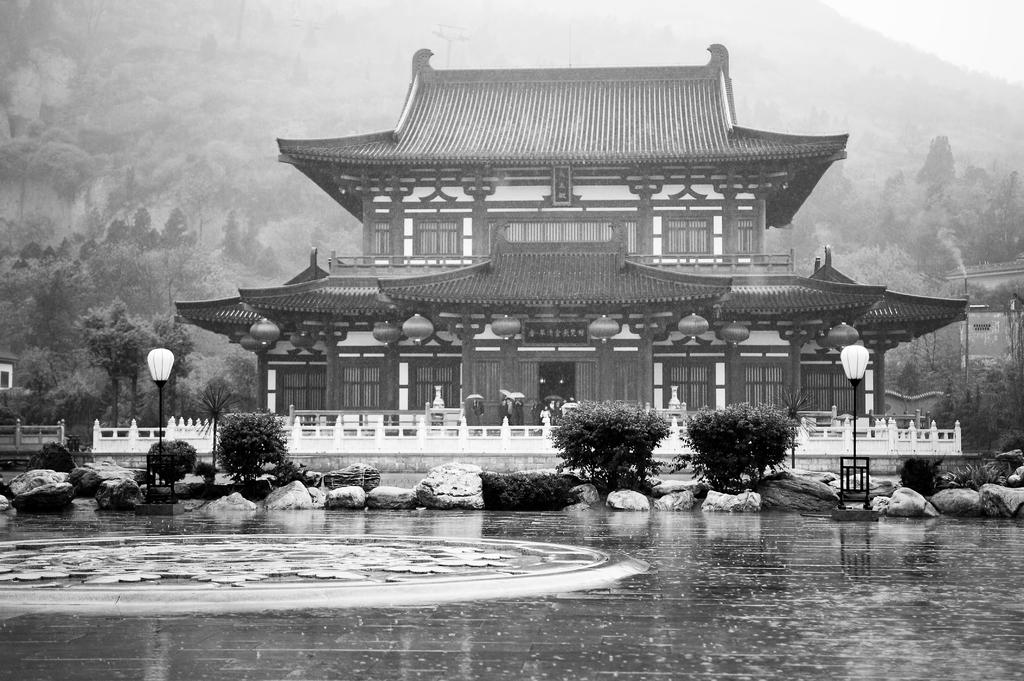What type of structure is visible in the image? There is a building in the image. What natural feature can be seen in the distance? There is a mountain in the backdrop of the image. What type of vegetation is present in the image? There are trees in the image. Can you see a donkey lying on a bed in the image? No, there is no donkey or bed present in the image. 